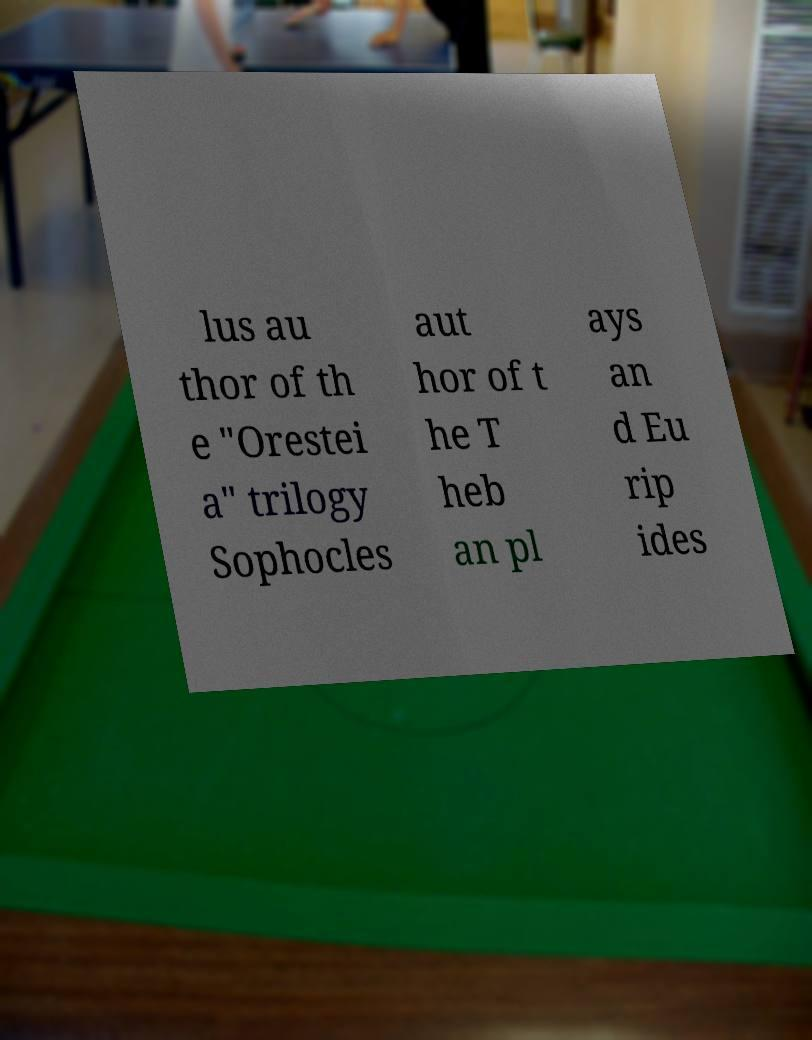What messages or text are displayed in this image? I need them in a readable, typed format. lus au thor of th e "Orestei a" trilogy Sophocles aut hor of t he T heb an pl ays an d Eu rip ides 